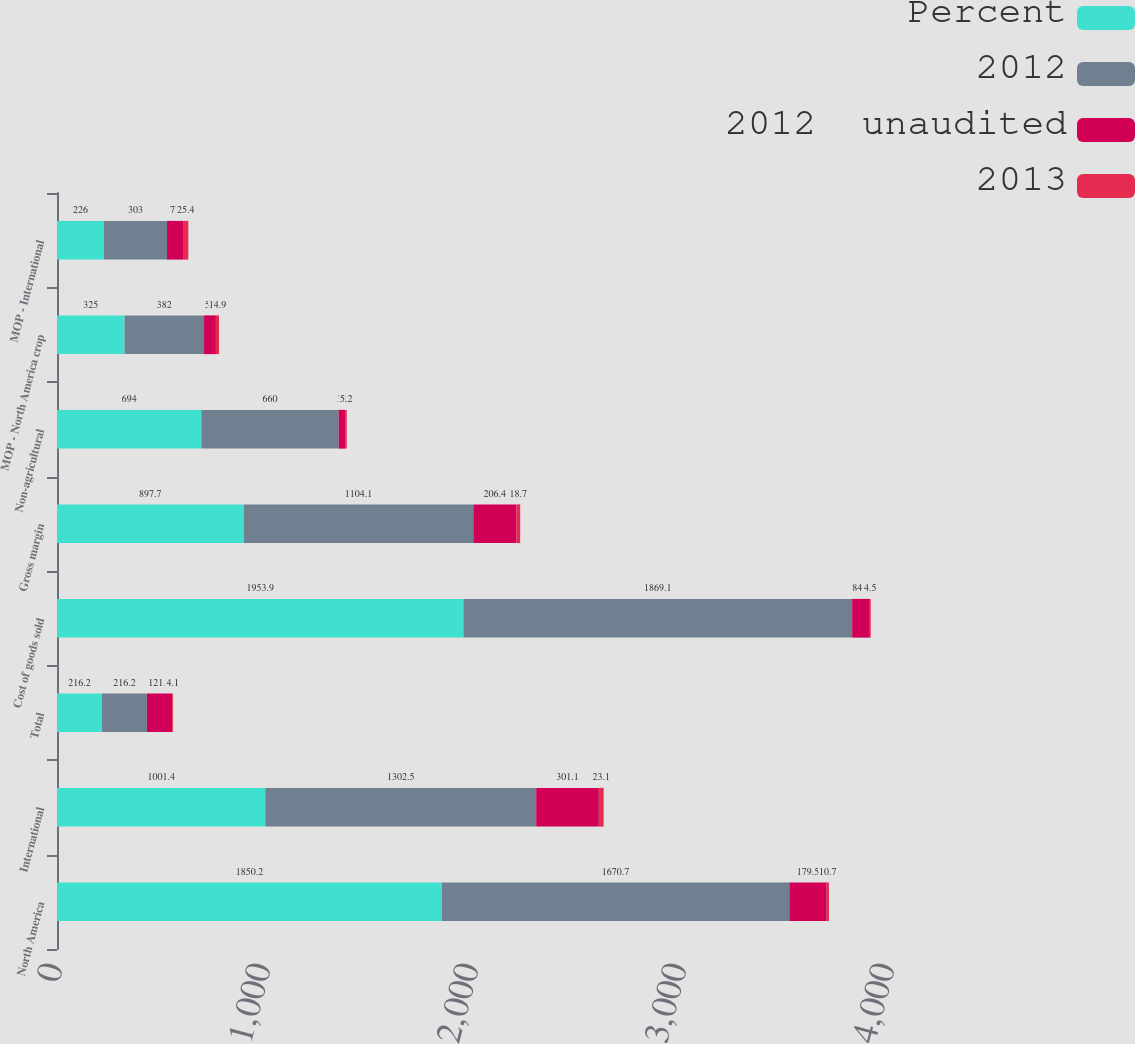<chart> <loc_0><loc_0><loc_500><loc_500><stacked_bar_chart><ecel><fcel>North America<fcel>International<fcel>Total<fcel>Cost of goods sold<fcel>Gross margin<fcel>Non-agricultural<fcel>MOP - North America crop<fcel>MOP - International<nl><fcel>Percent<fcel>1850.2<fcel>1001.4<fcel>216.2<fcel>1953.9<fcel>897.7<fcel>694<fcel>325<fcel>226<nl><fcel>2012<fcel>1670.7<fcel>1302.5<fcel>216.2<fcel>1869.1<fcel>1104.1<fcel>660<fcel>382<fcel>303<nl><fcel>2012  unaudited<fcel>179.5<fcel>301.1<fcel>121.6<fcel>84.8<fcel>206.4<fcel>34<fcel>57<fcel>77<nl><fcel>2013<fcel>10.7<fcel>23.1<fcel>4.1<fcel>4.5<fcel>18.7<fcel>5.2<fcel>14.9<fcel>25.4<nl></chart> 